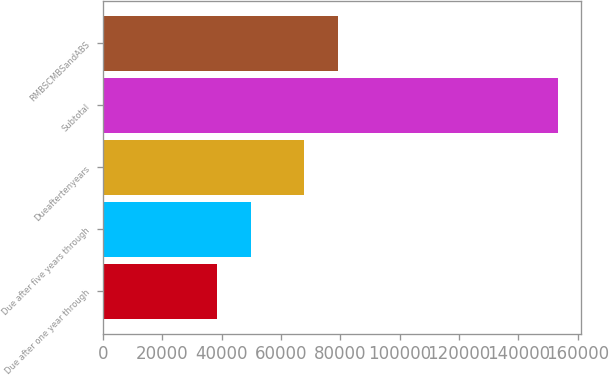Convert chart to OTSL. <chart><loc_0><loc_0><loc_500><loc_500><bar_chart><fcel>Due after one year through<fcel>Due after five years through<fcel>Dueaftertenyears<fcel>Subtotal<fcel>RMBSCMBSandABS<nl><fcel>38408<fcel>49921.1<fcel>67838<fcel>153539<fcel>79351.1<nl></chart> 